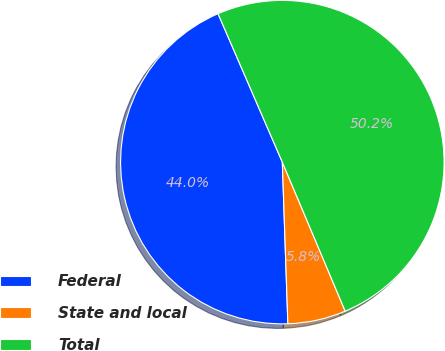<chart> <loc_0><loc_0><loc_500><loc_500><pie_chart><fcel>Federal<fcel>State and local<fcel>Total<nl><fcel>44.04%<fcel>5.81%<fcel>50.15%<nl></chart> 